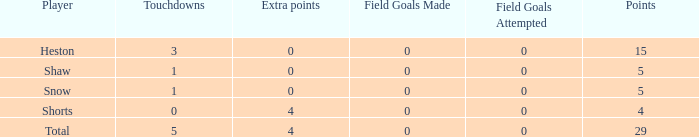What is the total number of field goals a player had when there were more than 0 extra points and there were 5 touchdowns? 1.0. 